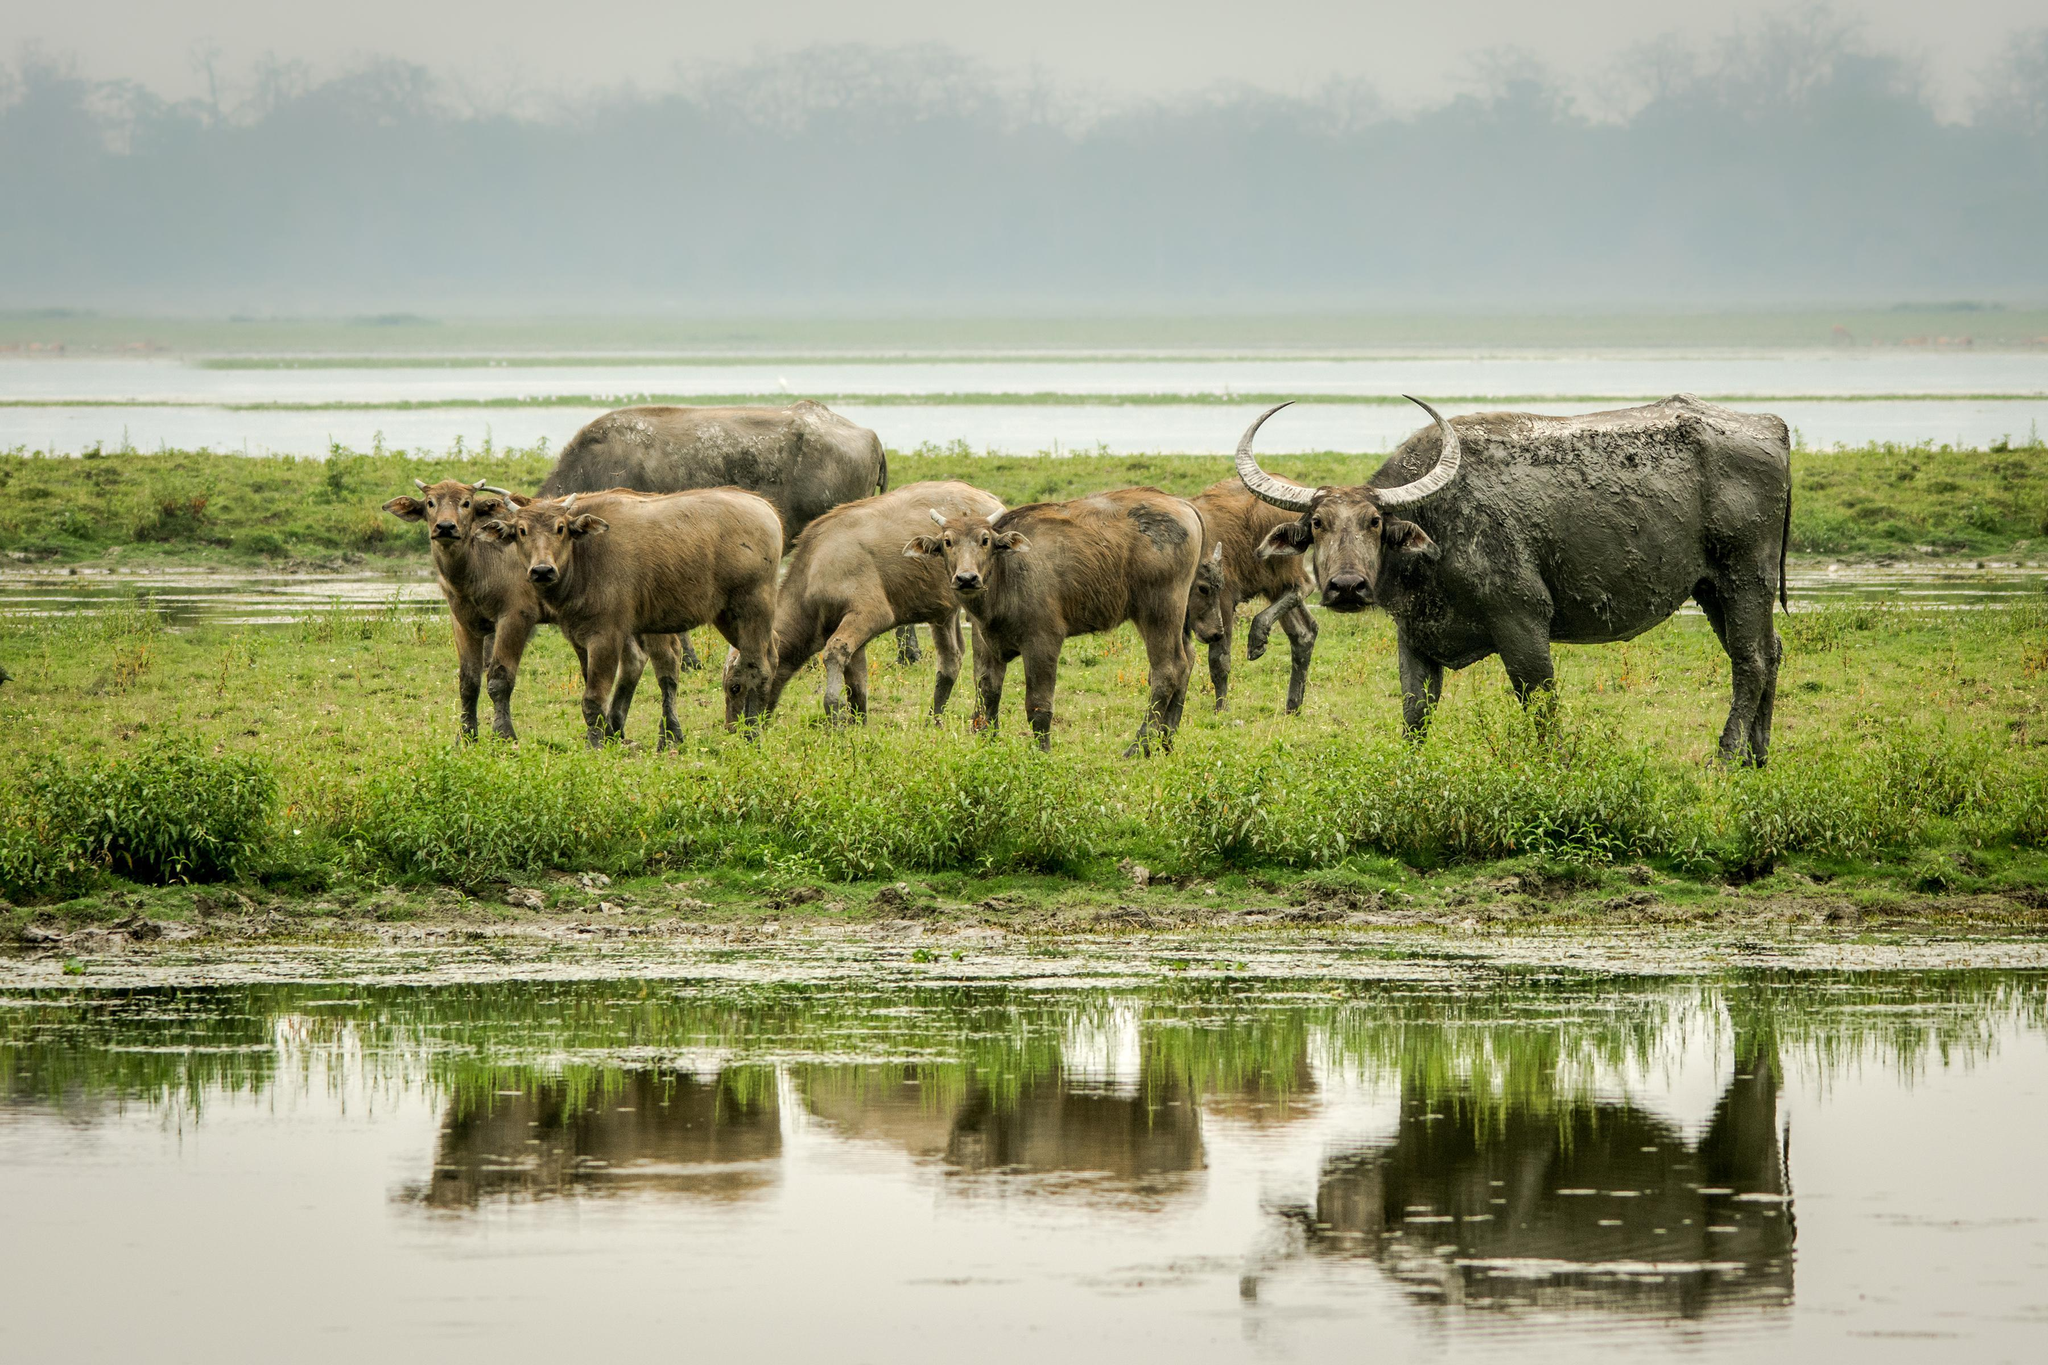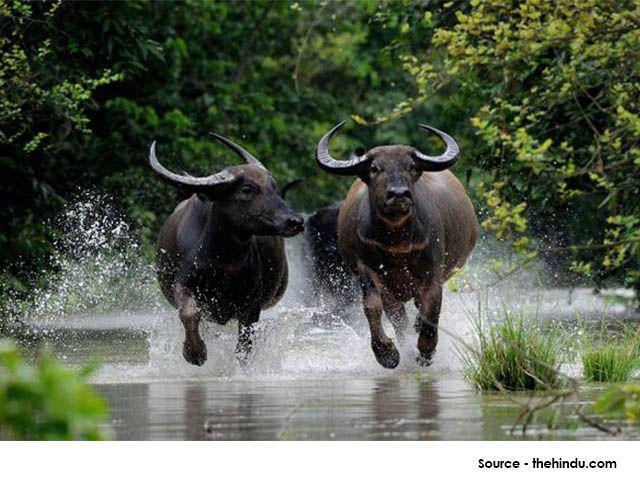The first image is the image on the left, the second image is the image on the right. Examine the images to the left and right. Is the description "An image shows exactly one water buffalo standing on muddy, wet ground." accurate? Answer yes or no. No. 